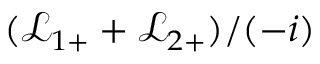<formula> <loc_0><loc_0><loc_500><loc_500>( \mathcal { L } _ { 1 + } + \mathcal { L } _ { 2 + } ) / ( - i )</formula> 